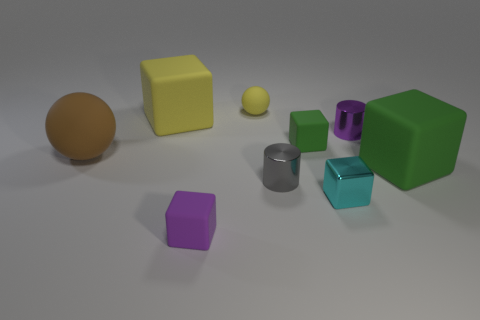Is the material of the cyan cube the same as the tiny purple object in front of the brown thing?
Offer a very short reply. No. Is the number of large brown balls that are right of the small shiny cube less than the number of small matte things that are behind the small green object?
Your response must be concise. Yes. There is a purple object behind the cyan thing; what is it made of?
Offer a very short reply. Metal. There is a object that is on the right side of the small cyan thing and behind the large brown matte object; what is its color?
Your response must be concise. Purple. What number of other objects are there of the same color as the large rubber sphere?
Ensure brevity in your answer.  0. What is the color of the small block that is behind the small gray object?
Provide a short and direct response. Green. Are there any brown rubber objects that have the same size as the gray metallic thing?
Make the answer very short. No. What is the material of the other cylinder that is the same size as the gray shiny cylinder?
Keep it short and to the point. Metal. How many objects are either matte spheres behind the purple shiny thing or yellow objects left of the small purple cube?
Provide a short and direct response. 2. Are there any other matte things of the same shape as the large yellow rubber object?
Offer a terse response. Yes. 